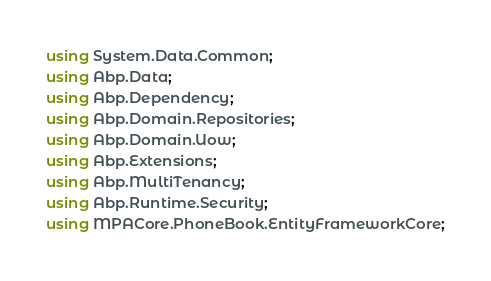Convert code to text. <code><loc_0><loc_0><loc_500><loc_500><_C#_>using System.Data.Common;
using Abp.Data;
using Abp.Dependency;
using Abp.Domain.Repositories;
using Abp.Domain.Uow;
using Abp.Extensions;
using Abp.MultiTenancy;
using Abp.Runtime.Security;
using MPACore.PhoneBook.EntityFrameworkCore;</code> 